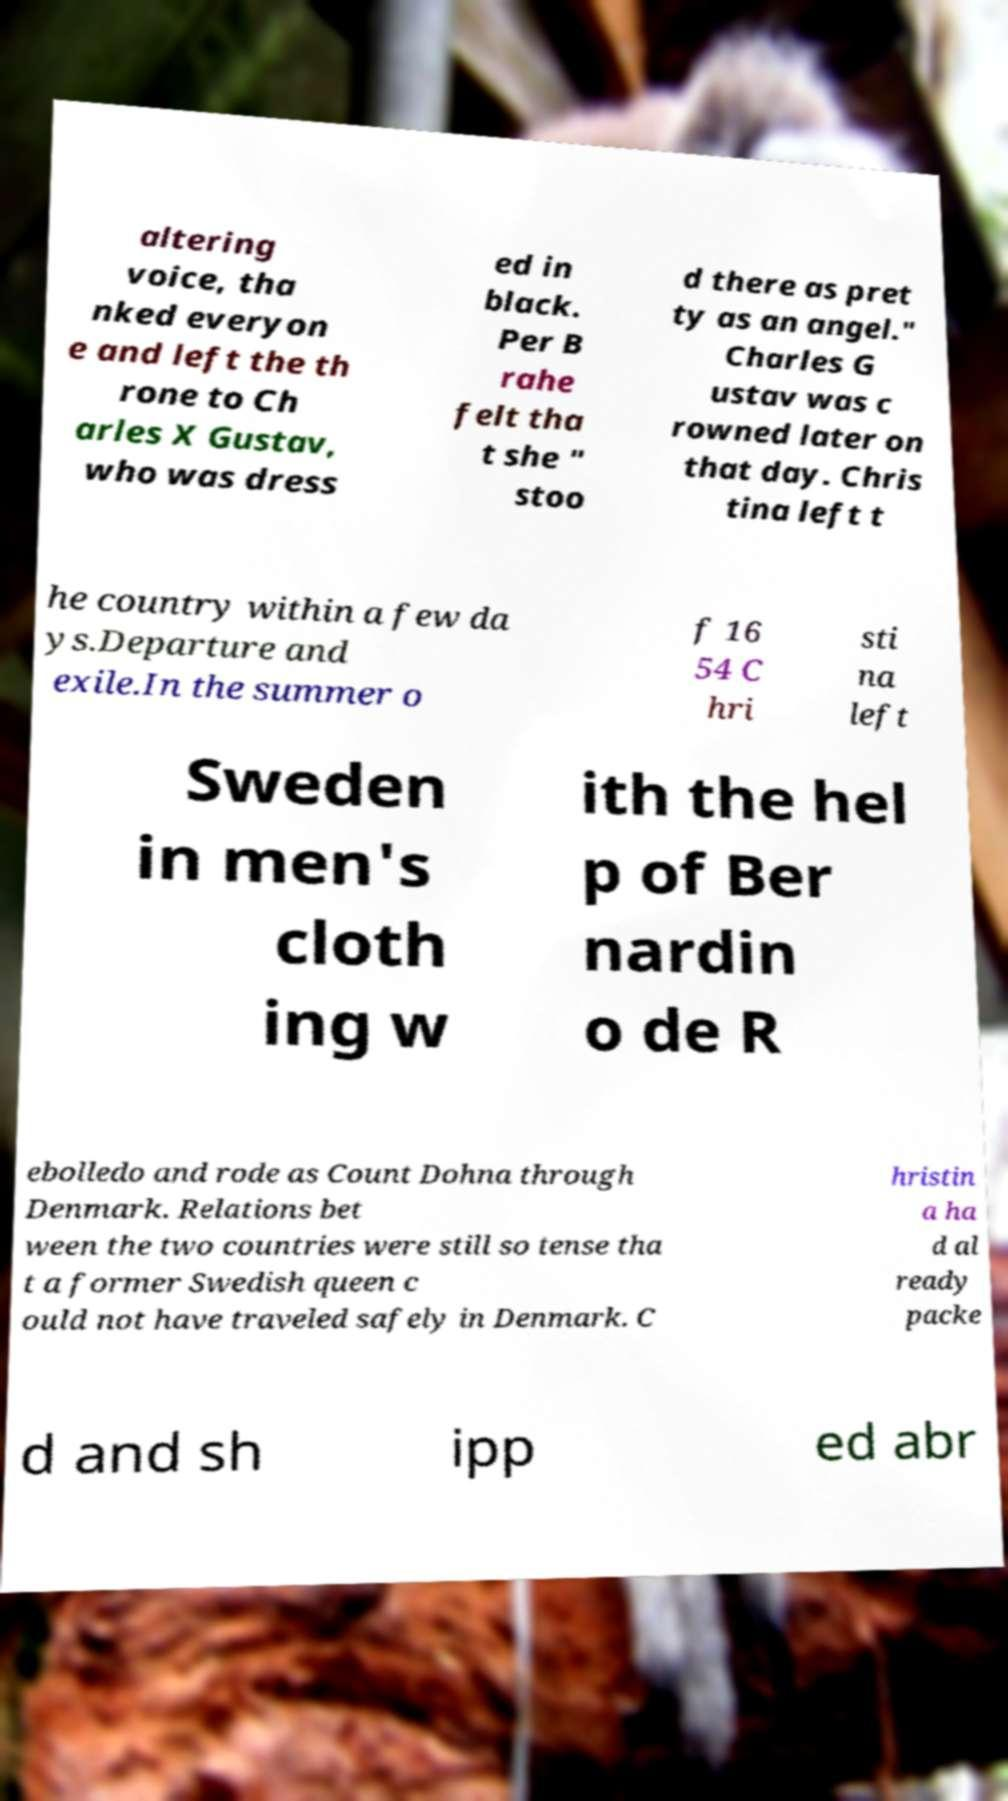Could you assist in decoding the text presented in this image and type it out clearly? altering voice, tha nked everyon e and left the th rone to Ch arles X Gustav, who was dress ed in black. Per B rahe felt tha t she " stoo d there as pret ty as an angel." Charles G ustav was c rowned later on that day. Chris tina left t he country within a few da ys.Departure and exile.In the summer o f 16 54 C hri sti na left Sweden in men's cloth ing w ith the hel p of Ber nardin o de R ebolledo and rode as Count Dohna through Denmark. Relations bet ween the two countries were still so tense tha t a former Swedish queen c ould not have traveled safely in Denmark. C hristin a ha d al ready packe d and sh ipp ed abr 